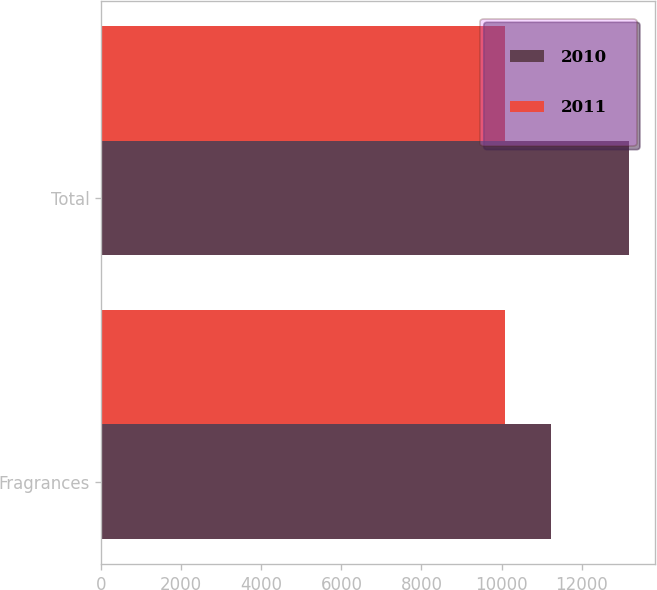Convert chart to OTSL. <chart><loc_0><loc_0><loc_500><loc_500><stacked_bar_chart><ecel><fcel>Fragrances<fcel>Total<nl><fcel>2010<fcel>11224<fcel>13172<nl><fcel>2011<fcel>10077<fcel>10077<nl></chart> 